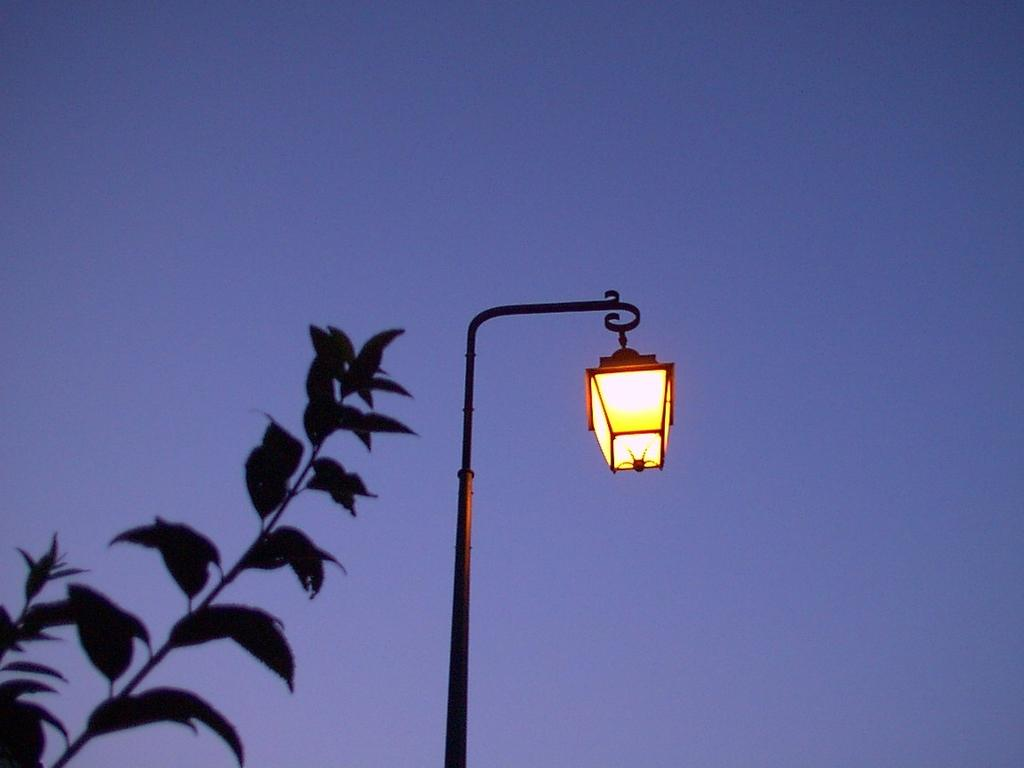What structure is present in the image? There is a light pole in the image. What else can be seen in the image besides the light pole? There is a branch in the image. What is visible in the background of the image? The sky is visible in the background of the image. What type of underwear is hanging from the light pole in the image? There is no underwear present in the image; it only features a light pole and a branch. 